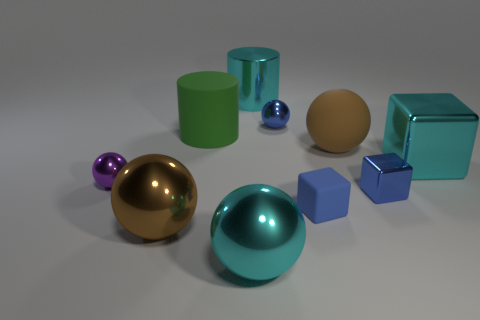Subtract all small metal spheres. How many spheres are left? 3 Subtract all blocks. How many objects are left? 7 Subtract all cyan cylinders. How many blue blocks are left? 2 Subtract all small blue cubes. Subtract all cyan cylinders. How many objects are left? 7 Add 6 brown spheres. How many brown spheres are left? 8 Add 8 brown matte cylinders. How many brown matte cylinders exist? 8 Subtract all purple spheres. How many spheres are left? 4 Subtract 0 green cubes. How many objects are left? 10 Subtract 1 spheres. How many spheres are left? 4 Subtract all yellow cylinders. Subtract all yellow cubes. How many cylinders are left? 2 